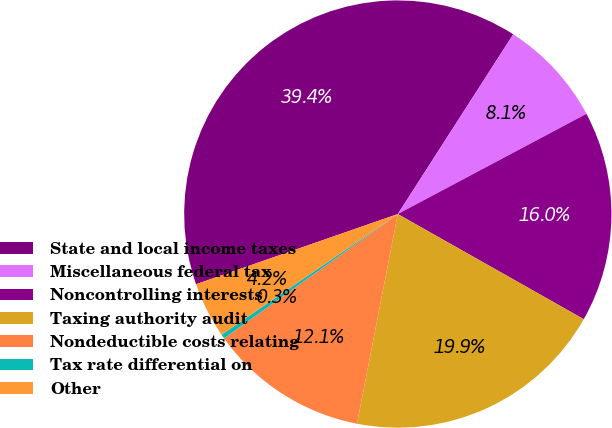<chart> <loc_0><loc_0><loc_500><loc_500><pie_chart><fcel>State and local income taxes<fcel>Miscellaneous federal tax<fcel>Noncontrolling interests<fcel>Taxing authority audit<fcel>Nondeductible costs relating<fcel>Tax rate differential on<fcel>Other<nl><fcel>39.41%<fcel>8.14%<fcel>15.96%<fcel>19.87%<fcel>12.05%<fcel>0.33%<fcel>4.23%<nl></chart> 